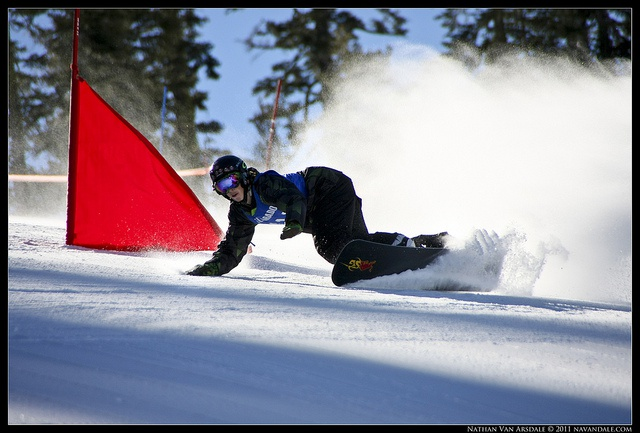Describe the objects in this image and their specific colors. I can see people in black, navy, white, and gray tones and snowboard in black, maroon, and gray tones in this image. 